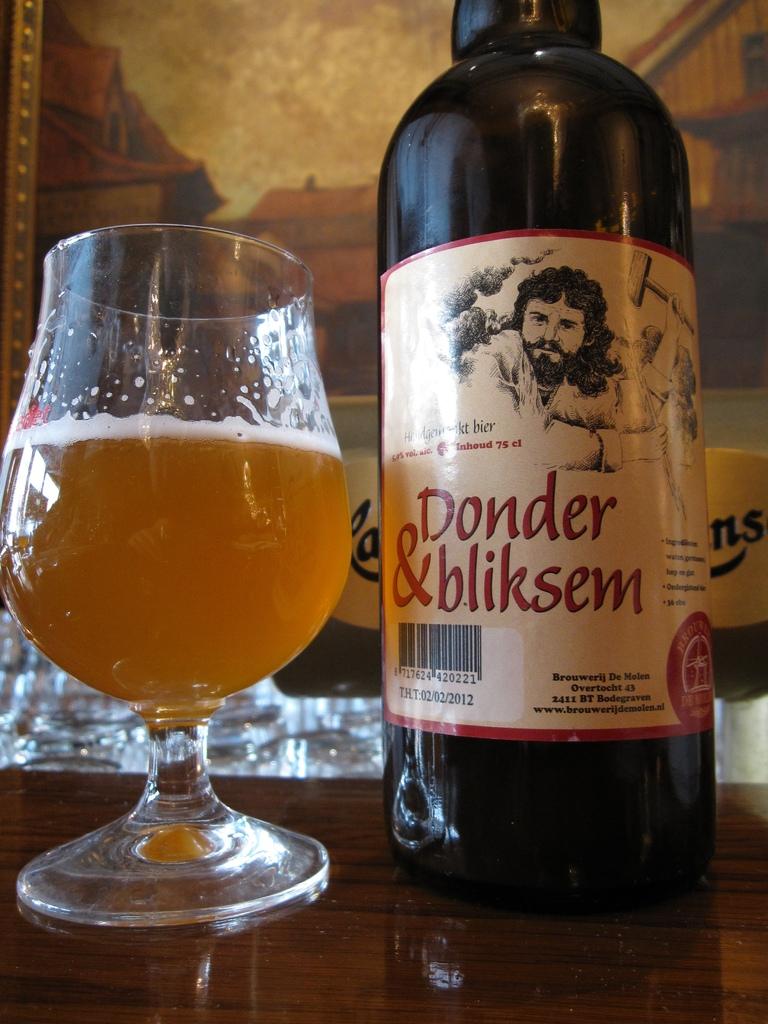What is the name of the beer?
Your answer should be compact. Donder & bliksem. When is the date below the barcode?
Offer a very short reply. 02/02/2012. 